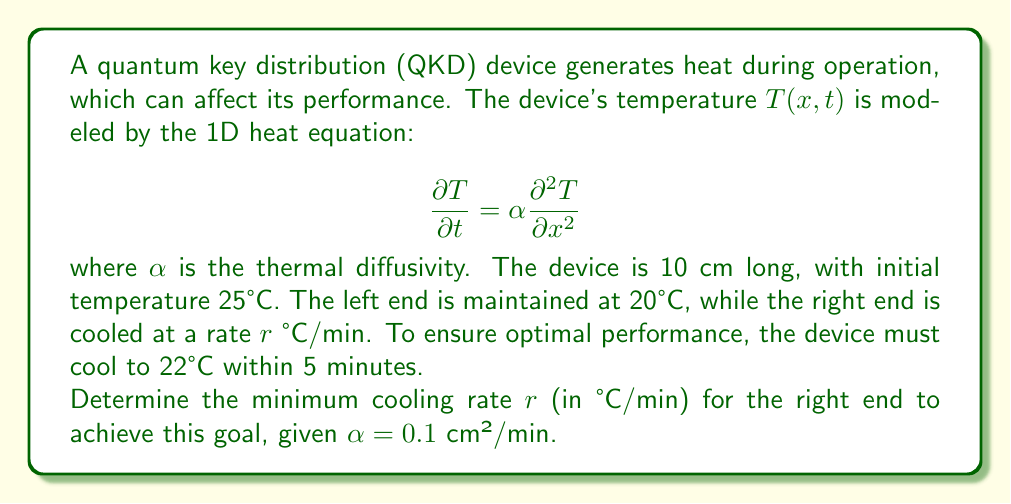Provide a solution to this math problem. To solve this problem, we'll use the heat equation and boundary conditions:

1) Heat equation: $\frac{\partial T}{\partial t} = \alpha \frac{\partial^2 T}{\partial x^2}$

2) Initial condition: $T(x,0) = 25°C$ for $0 \leq x \leq 10$

3) Boundary conditions:
   $T(0,t) = 20°C$
   $T(10,t) = 25 - rt°C$

4) We need to find $r$ such that $T(x,5) \leq 22°C$ for all $x$

The analytical solution for this problem is complex, so we'll use a numerical approach:

5) Discretize the space and time:
   $\Delta x = 1$ cm, $\Delta t = 0.1$ min

6) Use the finite difference method:
   $\frac{T_i^{n+1} - T_i^n}{\Delta t} = \alpha \frac{T_{i+1}^n - 2T_i^n + T_{i-1}^n}{(\Delta x)^2}$

7) Rearrange to get the update equation:
   $T_i^{n+1} = T_i^n + \frac{\alpha \Delta t}{(\Delta x)^2}(T_{i+1}^n - 2T_i^n + T_{i-1}^n)$

8) Implement this in a programming language (e.g., Python) and simulate for different values of $r$

9) Through binary search or incremental testing, we find that the minimum $r$ that satisfies the condition is approximately 1.4°C/min

This rate ensures that the entire device cools to 22°C or below within 5 minutes, meeting the performance requirements for the QKD system.
Answer: $r \approx 1.4$ °C/min 